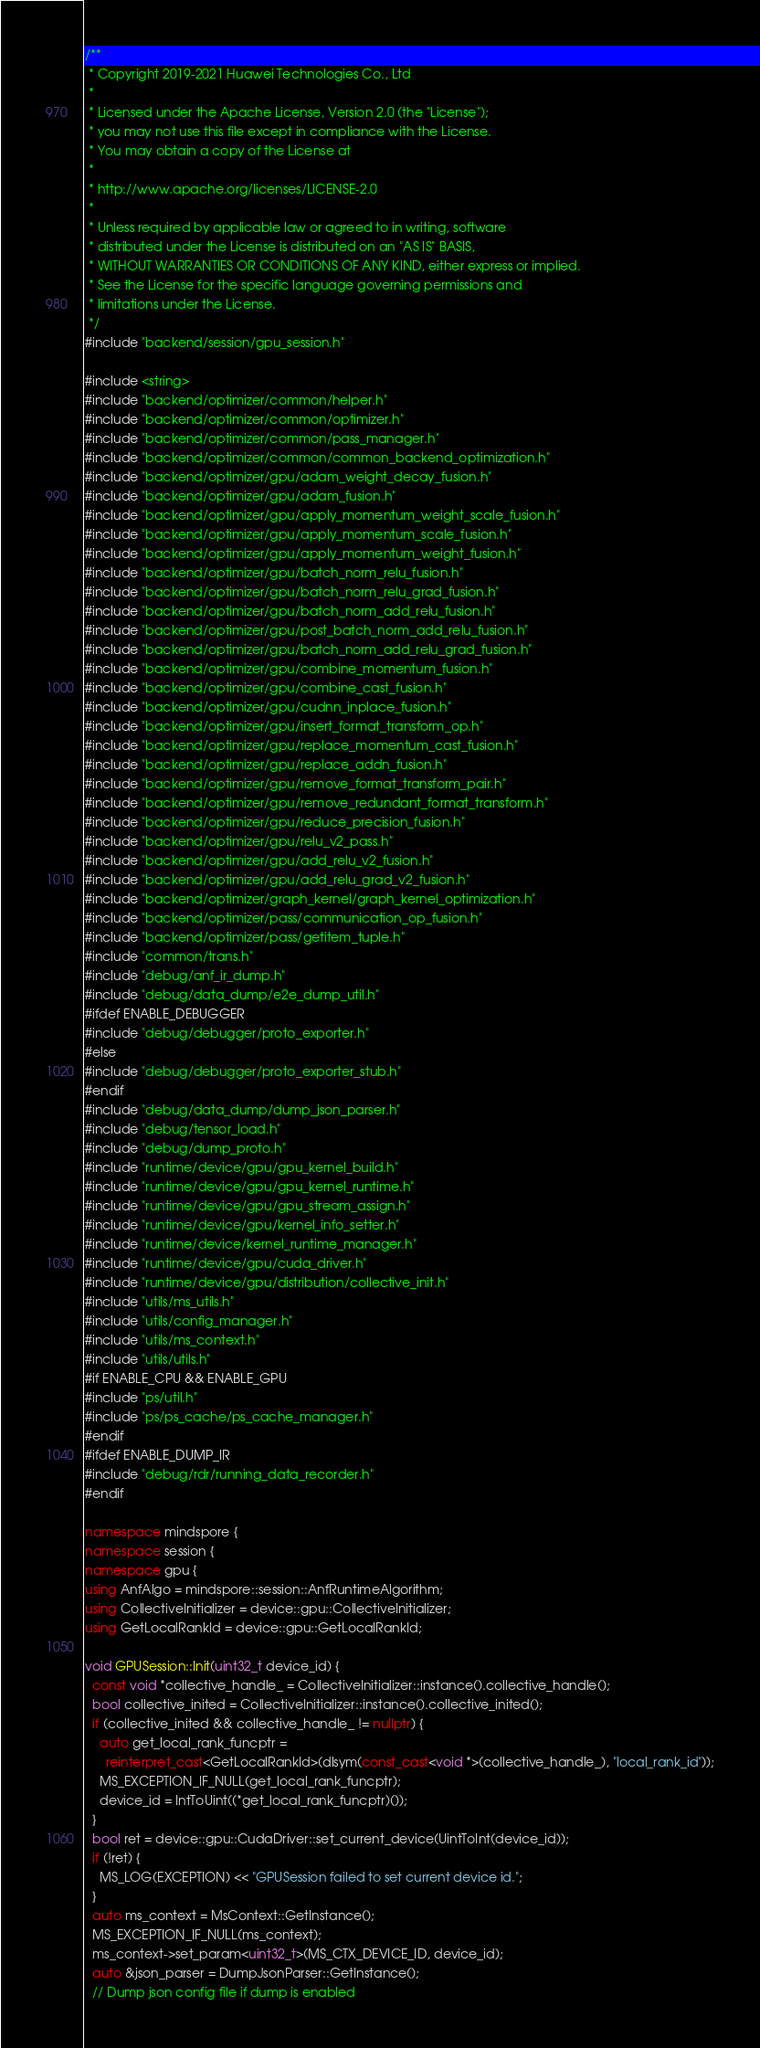Convert code to text. <code><loc_0><loc_0><loc_500><loc_500><_C++_>/**
 * Copyright 2019-2021 Huawei Technologies Co., Ltd
 *
 * Licensed under the Apache License, Version 2.0 (the "License");
 * you may not use this file except in compliance with the License.
 * You may obtain a copy of the License at
 *
 * http://www.apache.org/licenses/LICENSE-2.0
 *
 * Unless required by applicable law or agreed to in writing, software
 * distributed under the License is distributed on an "AS IS" BASIS,
 * WITHOUT WARRANTIES OR CONDITIONS OF ANY KIND, either express or implied.
 * See the License for the specific language governing permissions and
 * limitations under the License.
 */
#include "backend/session/gpu_session.h"

#include <string>
#include "backend/optimizer/common/helper.h"
#include "backend/optimizer/common/optimizer.h"
#include "backend/optimizer/common/pass_manager.h"
#include "backend/optimizer/common/common_backend_optimization.h"
#include "backend/optimizer/gpu/adam_weight_decay_fusion.h"
#include "backend/optimizer/gpu/adam_fusion.h"
#include "backend/optimizer/gpu/apply_momentum_weight_scale_fusion.h"
#include "backend/optimizer/gpu/apply_momentum_scale_fusion.h"
#include "backend/optimizer/gpu/apply_momentum_weight_fusion.h"
#include "backend/optimizer/gpu/batch_norm_relu_fusion.h"
#include "backend/optimizer/gpu/batch_norm_relu_grad_fusion.h"
#include "backend/optimizer/gpu/batch_norm_add_relu_fusion.h"
#include "backend/optimizer/gpu/post_batch_norm_add_relu_fusion.h"
#include "backend/optimizer/gpu/batch_norm_add_relu_grad_fusion.h"
#include "backend/optimizer/gpu/combine_momentum_fusion.h"
#include "backend/optimizer/gpu/combine_cast_fusion.h"
#include "backend/optimizer/gpu/cudnn_inplace_fusion.h"
#include "backend/optimizer/gpu/insert_format_transform_op.h"
#include "backend/optimizer/gpu/replace_momentum_cast_fusion.h"
#include "backend/optimizer/gpu/replace_addn_fusion.h"
#include "backend/optimizer/gpu/remove_format_transform_pair.h"
#include "backend/optimizer/gpu/remove_redundant_format_transform.h"
#include "backend/optimizer/gpu/reduce_precision_fusion.h"
#include "backend/optimizer/gpu/relu_v2_pass.h"
#include "backend/optimizer/gpu/add_relu_v2_fusion.h"
#include "backend/optimizer/gpu/add_relu_grad_v2_fusion.h"
#include "backend/optimizer/graph_kernel/graph_kernel_optimization.h"
#include "backend/optimizer/pass/communication_op_fusion.h"
#include "backend/optimizer/pass/getitem_tuple.h"
#include "common/trans.h"
#include "debug/anf_ir_dump.h"
#include "debug/data_dump/e2e_dump_util.h"
#ifdef ENABLE_DEBUGGER
#include "debug/debugger/proto_exporter.h"
#else
#include "debug/debugger/proto_exporter_stub.h"
#endif
#include "debug/data_dump/dump_json_parser.h"
#include "debug/tensor_load.h"
#include "debug/dump_proto.h"
#include "runtime/device/gpu/gpu_kernel_build.h"
#include "runtime/device/gpu/gpu_kernel_runtime.h"
#include "runtime/device/gpu/gpu_stream_assign.h"
#include "runtime/device/gpu/kernel_info_setter.h"
#include "runtime/device/kernel_runtime_manager.h"
#include "runtime/device/gpu/cuda_driver.h"
#include "runtime/device/gpu/distribution/collective_init.h"
#include "utils/ms_utils.h"
#include "utils/config_manager.h"
#include "utils/ms_context.h"
#include "utils/utils.h"
#if ENABLE_CPU && ENABLE_GPU
#include "ps/util.h"
#include "ps/ps_cache/ps_cache_manager.h"
#endif
#ifdef ENABLE_DUMP_IR
#include "debug/rdr/running_data_recorder.h"
#endif

namespace mindspore {
namespace session {
namespace gpu {
using AnfAlgo = mindspore::session::AnfRuntimeAlgorithm;
using CollectiveInitializer = device::gpu::CollectiveInitializer;
using GetLocalRankId = device::gpu::GetLocalRankId;

void GPUSession::Init(uint32_t device_id) {
  const void *collective_handle_ = CollectiveInitializer::instance().collective_handle();
  bool collective_inited = CollectiveInitializer::instance().collective_inited();
  if (collective_inited && collective_handle_ != nullptr) {
    auto get_local_rank_funcptr =
      reinterpret_cast<GetLocalRankId>(dlsym(const_cast<void *>(collective_handle_), "local_rank_id"));
    MS_EXCEPTION_IF_NULL(get_local_rank_funcptr);
    device_id = IntToUint((*get_local_rank_funcptr)());
  }
  bool ret = device::gpu::CudaDriver::set_current_device(UintToInt(device_id));
  if (!ret) {
    MS_LOG(EXCEPTION) << "GPUSession failed to set current device id.";
  }
  auto ms_context = MsContext::GetInstance();
  MS_EXCEPTION_IF_NULL(ms_context);
  ms_context->set_param<uint32_t>(MS_CTX_DEVICE_ID, device_id);
  auto &json_parser = DumpJsonParser::GetInstance();
  // Dump json config file if dump is enabled</code> 